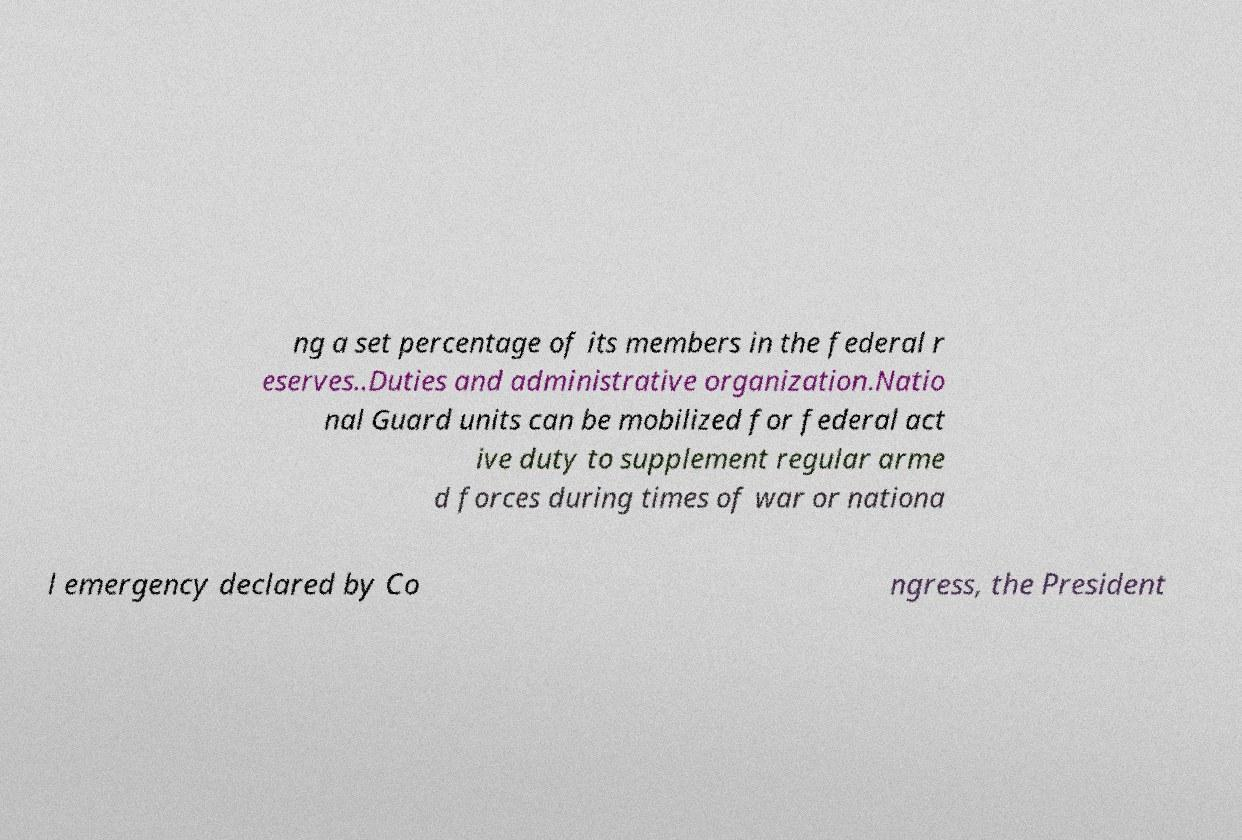Can you read and provide the text displayed in the image?This photo seems to have some interesting text. Can you extract and type it out for me? ng a set percentage of its members in the federal r eserves..Duties and administrative organization.Natio nal Guard units can be mobilized for federal act ive duty to supplement regular arme d forces during times of war or nationa l emergency declared by Co ngress, the President 